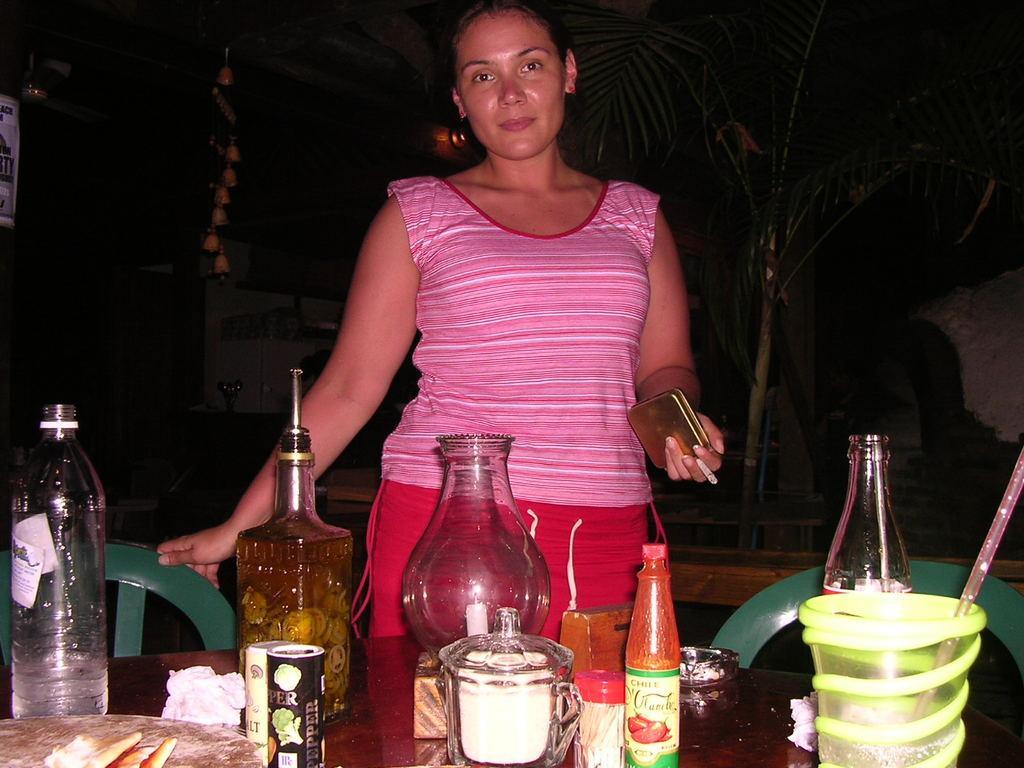Could you give a brief overview of what you see in this image? In this picture there is a woman who is holding a cigarette and wallet in her hand. There is a chair. There are few bottles on the table. There is a cup and a straw. 